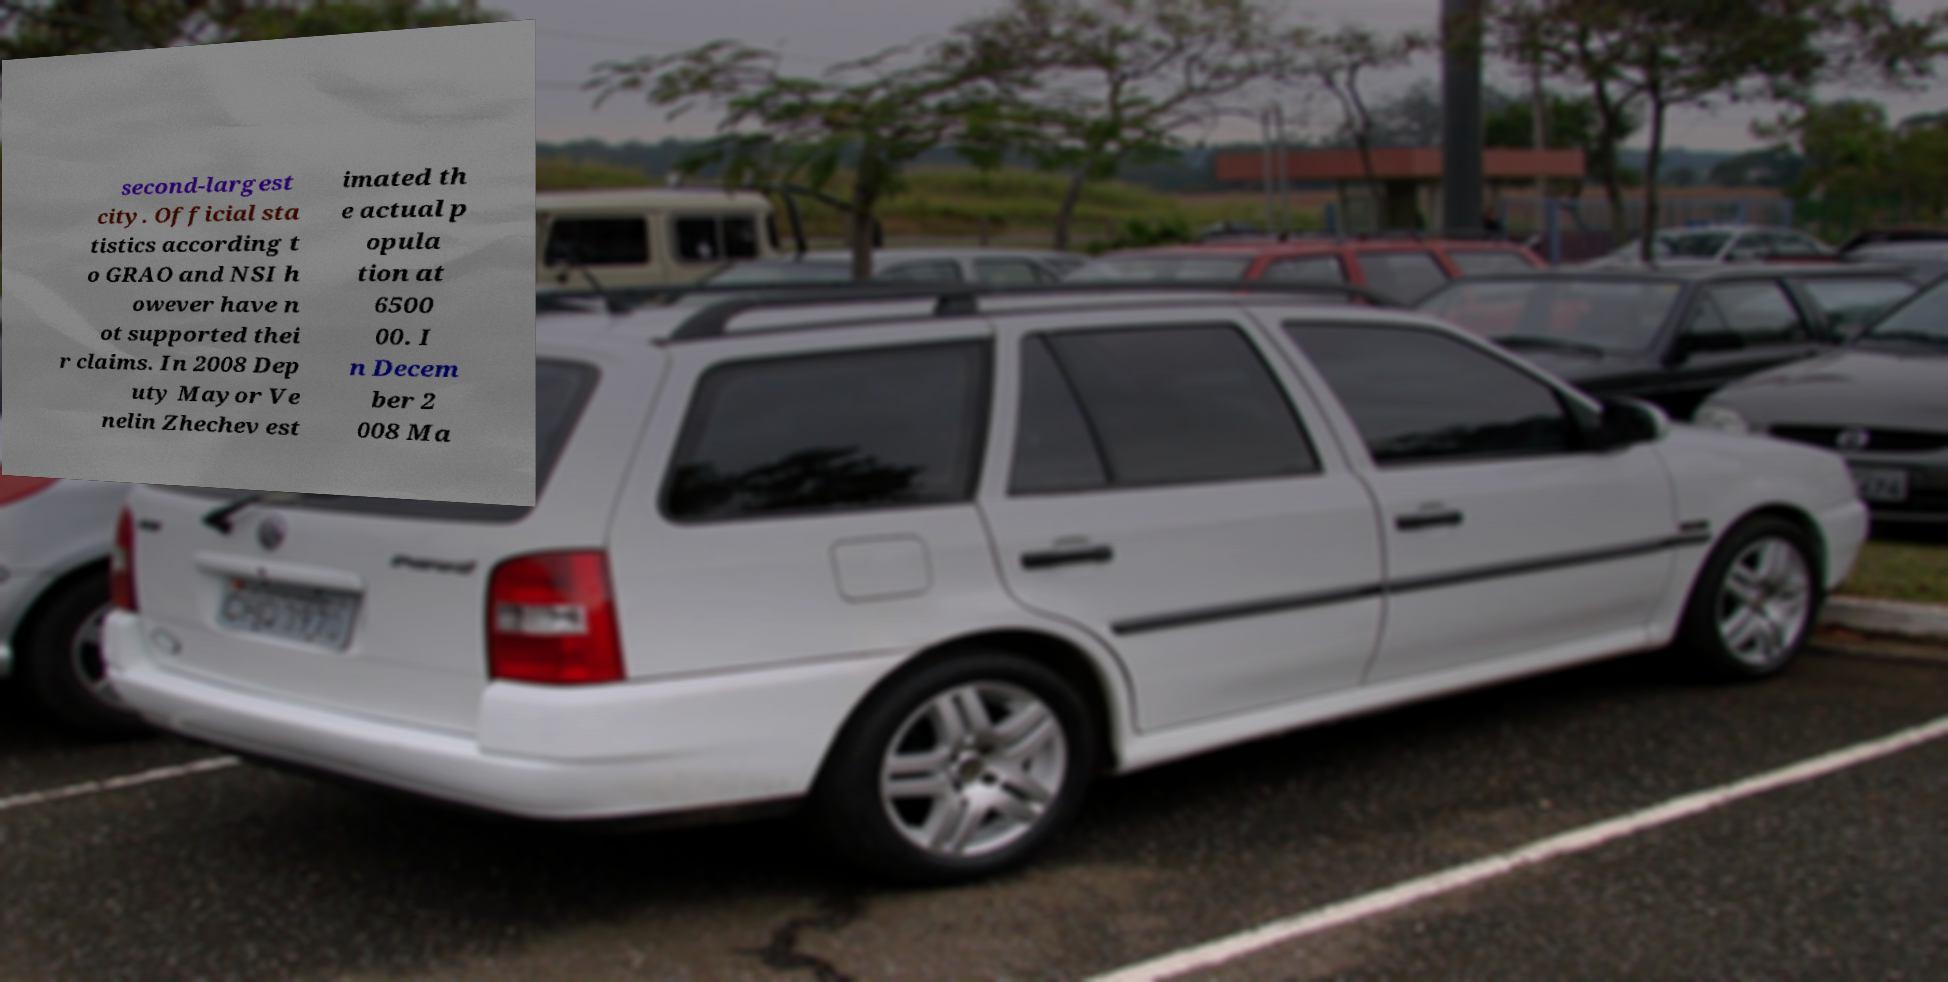Can you read and provide the text displayed in the image?This photo seems to have some interesting text. Can you extract and type it out for me? second-largest city. Official sta tistics according t o GRAO and NSI h owever have n ot supported thei r claims. In 2008 Dep uty Mayor Ve nelin Zhechev est imated th e actual p opula tion at 6500 00. I n Decem ber 2 008 Ma 